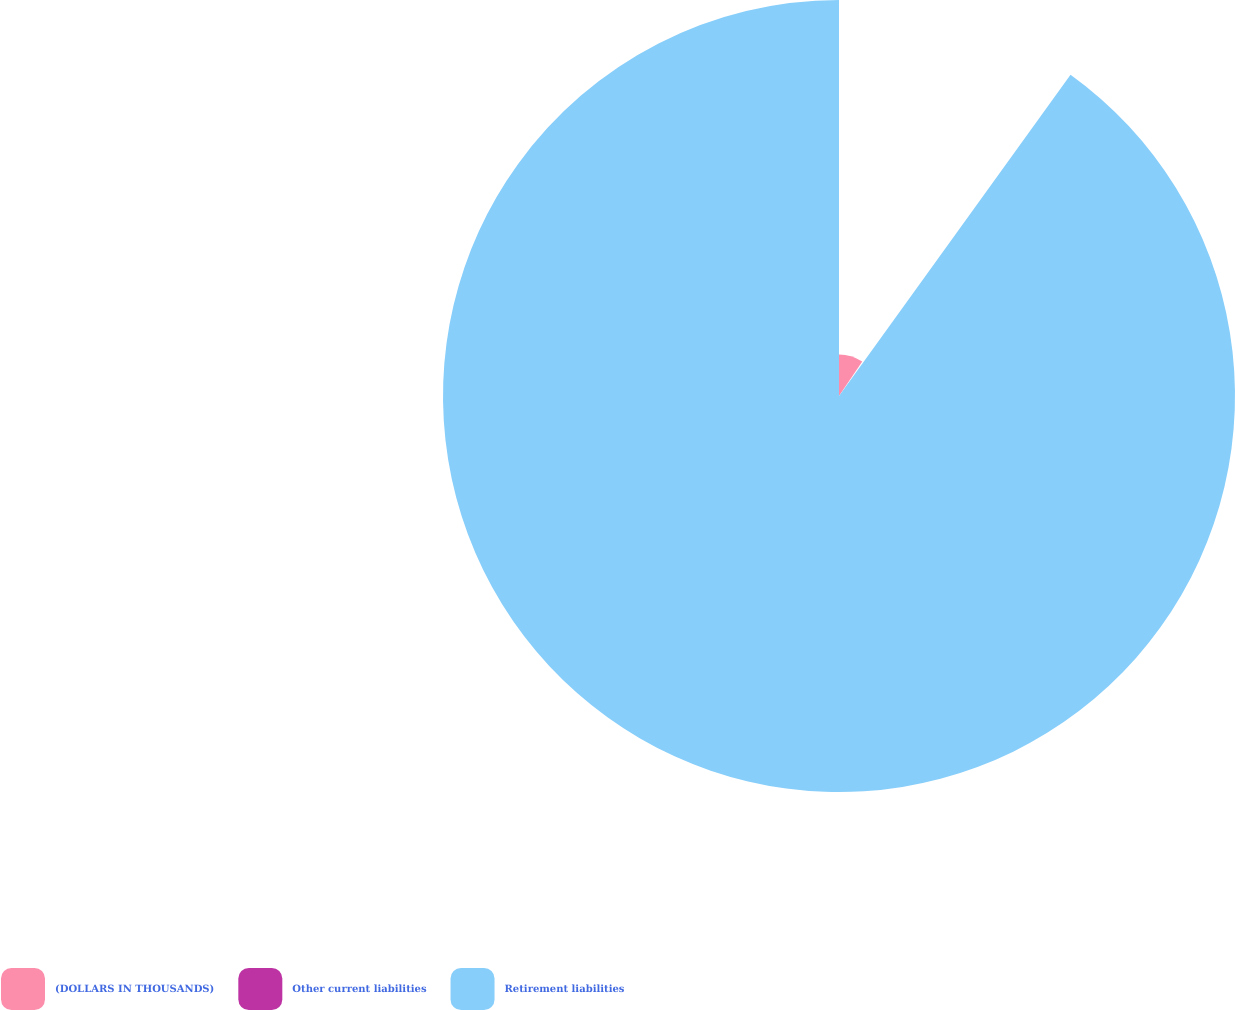Convert chart. <chart><loc_0><loc_0><loc_500><loc_500><pie_chart><fcel>(DOLLARS IN THOUSANDS)<fcel>Other current liabilities<fcel>Retirement liabilities<nl><fcel>9.45%<fcel>0.49%<fcel>90.07%<nl></chart> 